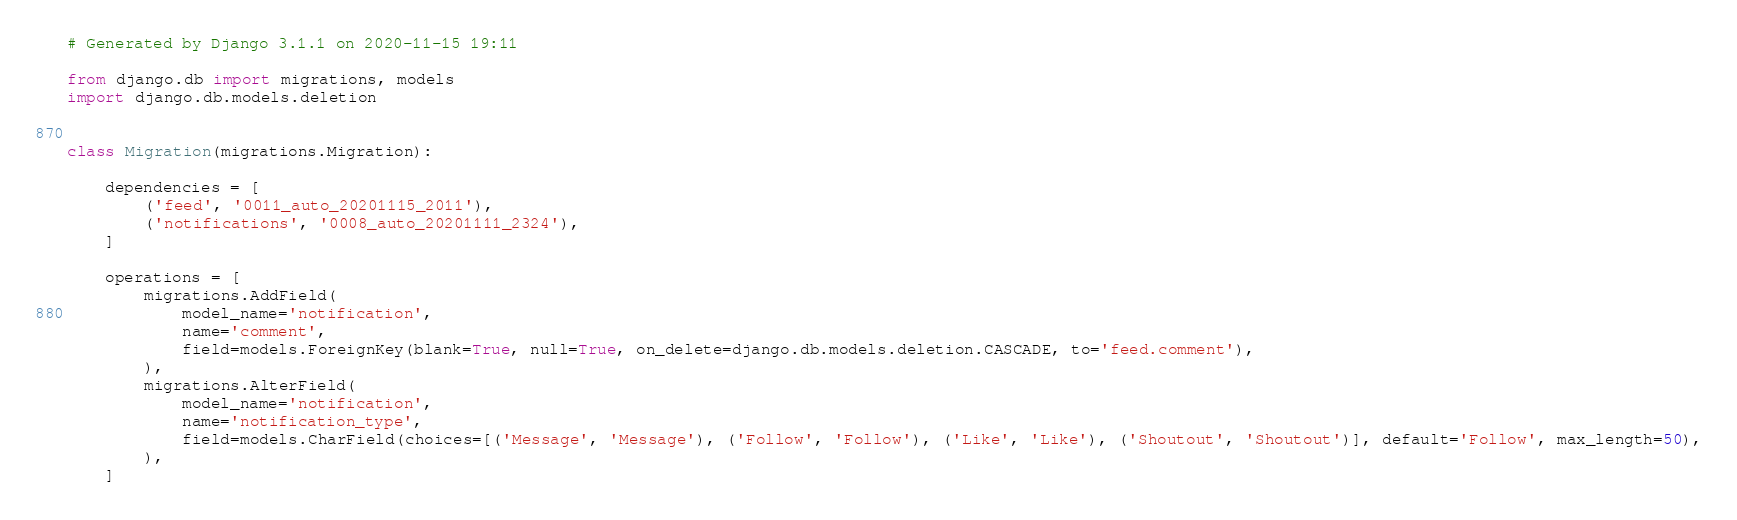Convert code to text. <code><loc_0><loc_0><loc_500><loc_500><_Python_># Generated by Django 3.1.1 on 2020-11-15 19:11

from django.db import migrations, models
import django.db.models.deletion


class Migration(migrations.Migration):

    dependencies = [
        ('feed', '0011_auto_20201115_2011'),
        ('notifications', '0008_auto_20201111_2324'),
    ]

    operations = [
        migrations.AddField(
            model_name='notification',
            name='comment',
            field=models.ForeignKey(blank=True, null=True, on_delete=django.db.models.deletion.CASCADE, to='feed.comment'),
        ),
        migrations.AlterField(
            model_name='notification',
            name='notification_type',
            field=models.CharField(choices=[('Message', 'Message'), ('Follow', 'Follow'), ('Like', 'Like'), ('Shoutout', 'Shoutout')], default='Follow', max_length=50),
        ),
    ]
</code> 